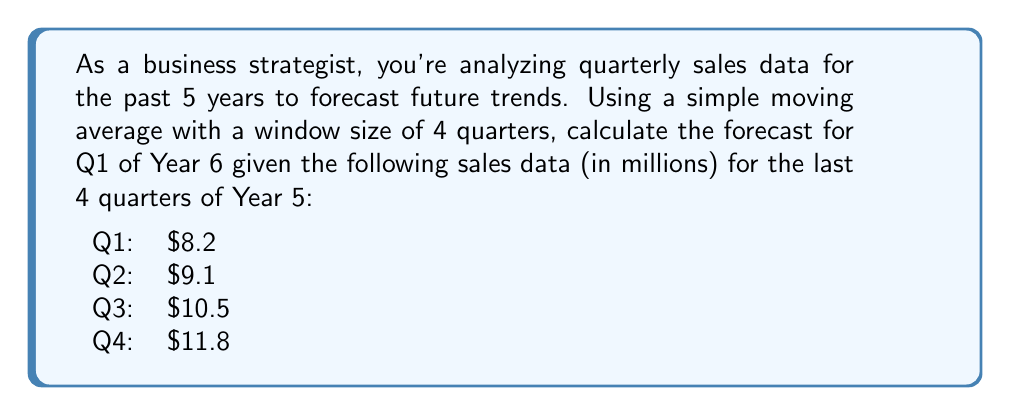What is the answer to this math problem? To forecast sales using a simple moving average with a window size of 4 quarters, we follow these steps:

1. Identify the data points for the last 4 quarters:
   Q1: $8.2 million
   Q2: $9.1 million
   Q3: $10.5 million
   Q4: $11.8 million

2. Calculate the sum of these 4 data points:
   $$8.2 + 9.1 + 10.5 + 11.8 = 39.6$$

3. Divide the sum by the number of data points (4) to get the simple moving average:
   $$\text{Forecast} = \frac{39.6}{4} = 9.9$$

Therefore, the forecast for Q1 of Year 6 using the simple moving average method is $9.9 million.

This method assumes that the trend observed in the past 4 quarters will continue into the next quarter. It's a basic forecasting technique that can be useful for short-term predictions in relatively stable markets.
Answer: $9.9 million 